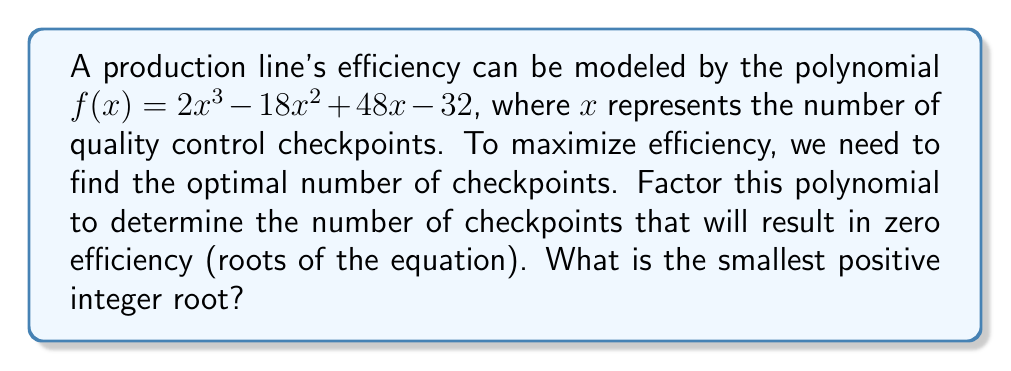Can you solve this math problem? To solve this problem, we need to factor the polynomial $f(x) = 2x^3 - 18x^2 + 48x - 32$.

Step 1: Factor out the greatest common factor (GCF).
$f(x) = 2(x^3 - 9x^2 + 24x - 16)$

Step 2: Try to identify a factor by guessing roots. Let's try $x = 2$.
$f(2) = 2(2^3 - 9(2^2) + 24(2) - 16) = 2(8 - 36 + 48 - 16) = 2(4) = 8$

Since $f(2) = 8$, $x - 2$ is not a factor. Let's try $x = 4$.
$f(4) = 2(4^3 - 9(4^2) + 24(4) - 16) = 2(64 - 144 + 96 - 16) = 2(0) = 0$

Therefore, $(x - 4)$ is a factor.

Step 3: Divide the polynomial by $(x - 4)$ using polynomial long division.
$x^3 - 9x^2 + 24x - 16 = (x - 4)(x^2 - 5x + 4)$

Step 4: Factor the quadratic term $(x^2 - 5x + 4)$.
$x^2 - 5x + 4 = (x - 1)(x - 4)$

Step 5: Combine all factors.
$f(x) = 2(x - 4)(x - 1)(x - 4)$
$f(x) = 2(x - 4)^2(x - 1)$

The roots of the equation are $x = 4$ (with multiplicity 2) and $x = 1$.
Answer: 1 